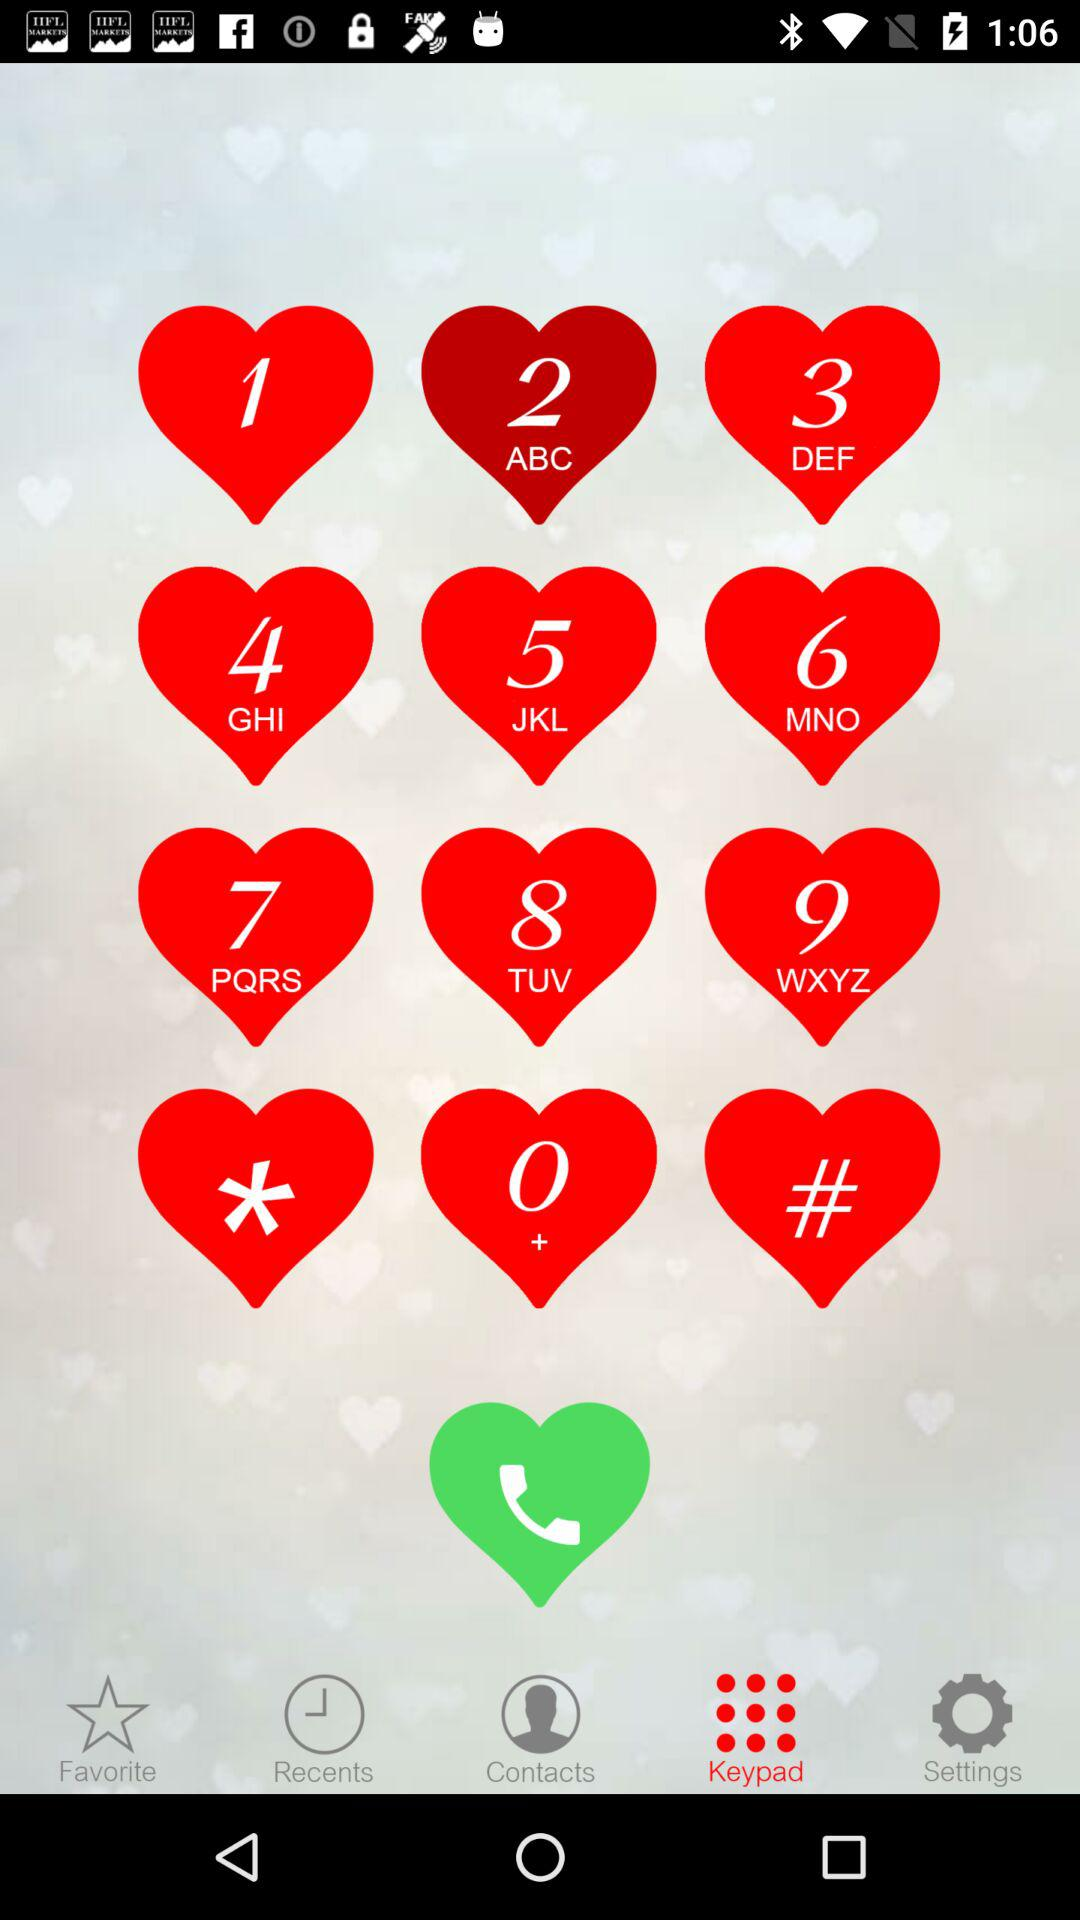Which is the selected tab? The selected tab is "Keypad". 